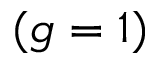Convert formula to latex. <formula><loc_0><loc_0><loc_500><loc_500>( g = 1 )</formula> 